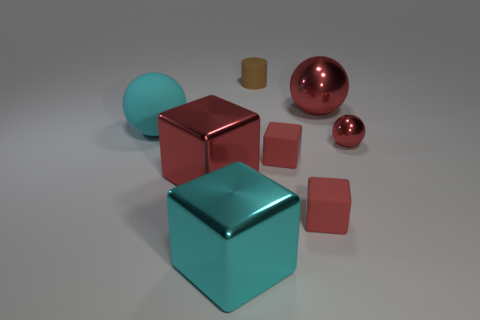Add 2 red rubber things. How many objects exist? 10 Subtract all red spheres. How many spheres are left? 1 Subtract all big shiny balls. How many balls are left? 2 Subtract all cylinders. How many objects are left? 7 Subtract 2 blocks. How many blocks are left? 2 Subtract all green blocks. Subtract all yellow cylinders. How many blocks are left? 4 Subtract all yellow spheres. How many cyan blocks are left? 1 Subtract all big green matte objects. Subtract all big things. How many objects are left? 4 Add 7 brown matte things. How many brown matte things are left? 8 Add 8 large blue blocks. How many large blue blocks exist? 8 